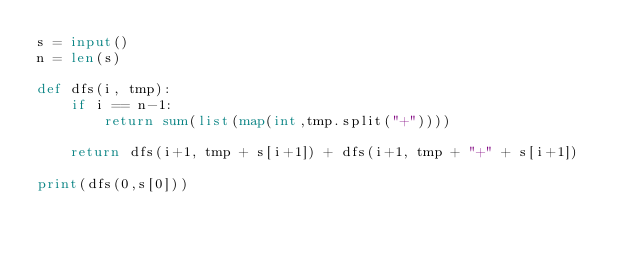Convert code to text. <code><loc_0><loc_0><loc_500><loc_500><_Python_>s = input()
n = len(s)

def dfs(i, tmp):
    if i == n-1:
        return sum(list(map(int,tmp.split("+"))))
    
    return dfs(i+1, tmp + s[i+1]) + dfs(i+1, tmp + "+" + s[i+1])

print(dfs(0,s[0]))</code> 